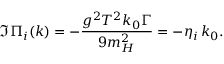Convert formula to latex. <formula><loc_0><loc_0><loc_500><loc_500>\Im \Pi _ { i } ( k ) = - \frac { g ^ { 2 } T ^ { 2 } k _ { 0 } \Gamma } { 9 m _ { H } ^ { 2 } } = - \eta _ { i } \, k _ { 0 } .</formula> 